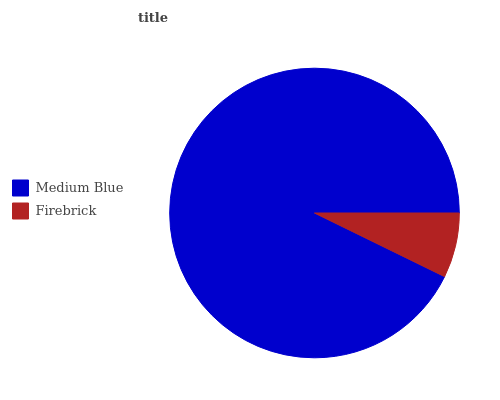Is Firebrick the minimum?
Answer yes or no. Yes. Is Medium Blue the maximum?
Answer yes or no. Yes. Is Firebrick the maximum?
Answer yes or no. No. Is Medium Blue greater than Firebrick?
Answer yes or no. Yes. Is Firebrick less than Medium Blue?
Answer yes or no. Yes. Is Firebrick greater than Medium Blue?
Answer yes or no. No. Is Medium Blue less than Firebrick?
Answer yes or no. No. Is Medium Blue the high median?
Answer yes or no. Yes. Is Firebrick the low median?
Answer yes or no. Yes. Is Firebrick the high median?
Answer yes or no. No. Is Medium Blue the low median?
Answer yes or no. No. 